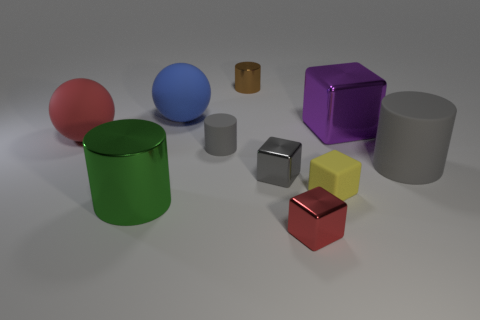How many different colors are present among the objects in the image? The image features objects in seven distinct colors: red, green, blue, yellow, purple, gray, and brown. 